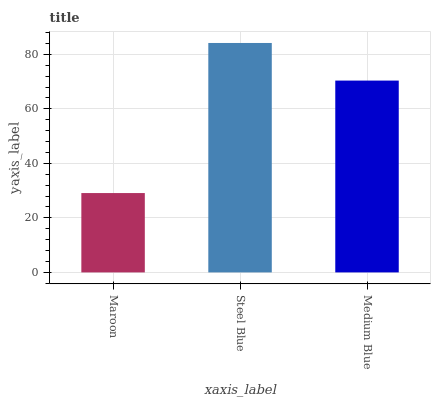Is Maroon the minimum?
Answer yes or no. Yes. Is Steel Blue the maximum?
Answer yes or no. Yes. Is Medium Blue the minimum?
Answer yes or no. No. Is Medium Blue the maximum?
Answer yes or no. No. Is Steel Blue greater than Medium Blue?
Answer yes or no. Yes. Is Medium Blue less than Steel Blue?
Answer yes or no. Yes. Is Medium Blue greater than Steel Blue?
Answer yes or no. No. Is Steel Blue less than Medium Blue?
Answer yes or no. No. Is Medium Blue the high median?
Answer yes or no. Yes. Is Medium Blue the low median?
Answer yes or no. Yes. Is Steel Blue the high median?
Answer yes or no. No. Is Maroon the low median?
Answer yes or no. No. 